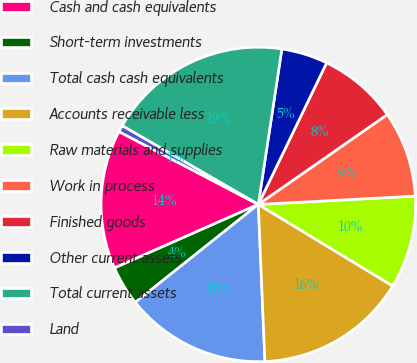<chart> <loc_0><loc_0><loc_500><loc_500><pie_chart><fcel>Cash and cash equivalents<fcel>Short-term investments<fcel>Total cash cash equivalents<fcel>Accounts receivable less<fcel>Raw materials and supplies<fcel>Work in process<fcel>Finished goods<fcel>Other current assets<fcel>Total current assets<fcel>Land<nl><fcel>14.29%<fcel>4.08%<fcel>14.97%<fcel>15.65%<fcel>9.52%<fcel>8.84%<fcel>8.16%<fcel>4.76%<fcel>19.05%<fcel>0.68%<nl></chart> 